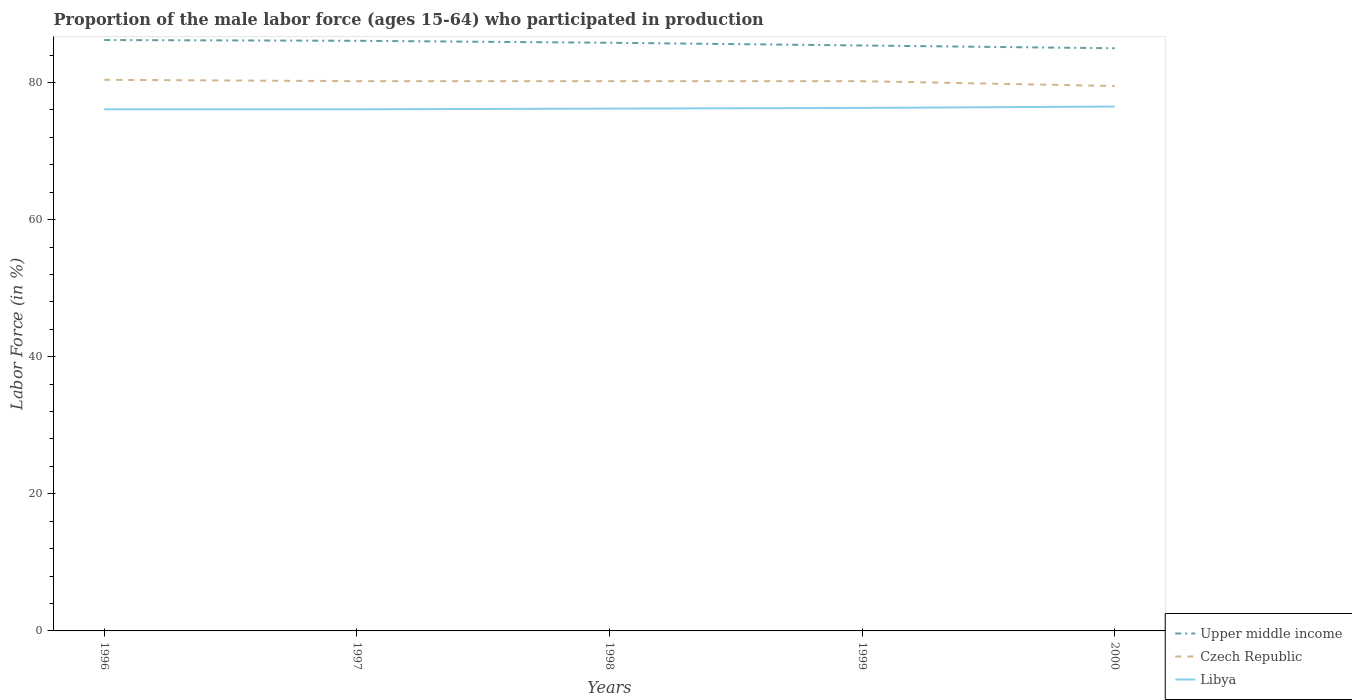How many different coloured lines are there?
Your answer should be very brief. 3. Across all years, what is the maximum proportion of the male labor force who participated in production in Upper middle income?
Offer a terse response. 85. In which year was the proportion of the male labor force who participated in production in Czech Republic maximum?
Offer a very short reply. 2000. What is the total proportion of the male labor force who participated in production in Libya in the graph?
Your answer should be very brief. -0.4. What is the difference between the highest and the second highest proportion of the male labor force who participated in production in Libya?
Provide a succinct answer. 0.4. Is the proportion of the male labor force who participated in production in Czech Republic strictly greater than the proportion of the male labor force who participated in production in Libya over the years?
Give a very brief answer. No. What is the difference between two consecutive major ticks on the Y-axis?
Your answer should be very brief. 20. Does the graph contain grids?
Your answer should be compact. No. Where does the legend appear in the graph?
Ensure brevity in your answer.  Bottom right. What is the title of the graph?
Make the answer very short. Proportion of the male labor force (ages 15-64) who participated in production. Does "Tonga" appear as one of the legend labels in the graph?
Offer a terse response. No. What is the Labor Force (in %) in Upper middle income in 1996?
Keep it short and to the point. 86.2. What is the Labor Force (in %) in Czech Republic in 1996?
Offer a terse response. 80.4. What is the Labor Force (in %) in Libya in 1996?
Provide a short and direct response. 76.1. What is the Labor Force (in %) of Upper middle income in 1997?
Your answer should be very brief. 86.09. What is the Labor Force (in %) in Czech Republic in 1997?
Your response must be concise. 80.2. What is the Labor Force (in %) of Libya in 1997?
Offer a terse response. 76.1. What is the Labor Force (in %) of Upper middle income in 1998?
Your answer should be very brief. 85.81. What is the Labor Force (in %) of Czech Republic in 1998?
Ensure brevity in your answer.  80.2. What is the Labor Force (in %) in Libya in 1998?
Ensure brevity in your answer.  76.2. What is the Labor Force (in %) in Upper middle income in 1999?
Your answer should be very brief. 85.41. What is the Labor Force (in %) in Czech Republic in 1999?
Your response must be concise. 80.2. What is the Labor Force (in %) in Libya in 1999?
Your answer should be compact. 76.3. What is the Labor Force (in %) in Upper middle income in 2000?
Offer a terse response. 85. What is the Labor Force (in %) in Czech Republic in 2000?
Provide a succinct answer. 79.5. What is the Labor Force (in %) in Libya in 2000?
Ensure brevity in your answer.  76.5. Across all years, what is the maximum Labor Force (in %) in Upper middle income?
Your answer should be compact. 86.2. Across all years, what is the maximum Labor Force (in %) of Czech Republic?
Keep it short and to the point. 80.4. Across all years, what is the maximum Labor Force (in %) of Libya?
Give a very brief answer. 76.5. Across all years, what is the minimum Labor Force (in %) of Upper middle income?
Offer a terse response. 85. Across all years, what is the minimum Labor Force (in %) of Czech Republic?
Provide a short and direct response. 79.5. Across all years, what is the minimum Labor Force (in %) of Libya?
Ensure brevity in your answer.  76.1. What is the total Labor Force (in %) of Upper middle income in the graph?
Offer a very short reply. 428.51. What is the total Labor Force (in %) of Czech Republic in the graph?
Ensure brevity in your answer.  400.5. What is the total Labor Force (in %) of Libya in the graph?
Make the answer very short. 381.2. What is the difference between the Labor Force (in %) in Upper middle income in 1996 and that in 1997?
Offer a terse response. 0.11. What is the difference between the Labor Force (in %) in Upper middle income in 1996 and that in 1998?
Provide a short and direct response. 0.4. What is the difference between the Labor Force (in %) of Libya in 1996 and that in 1998?
Your answer should be very brief. -0.1. What is the difference between the Labor Force (in %) of Upper middle income in 1996 and that in 1999?
Keep it short and to the point. 0.79. What is the difference between the Labor Force (in %) in Libya in 1996 and that in 1999?
Give a very brief answer. -0.2. What is the difference between the Labor Force (in %) in Upper middle income in 1996 and that in 2000?
Your answer should be very brief. 1.2. What is the difference between the Labor Force (in %) in Upper middle income in 1997 and that in 1998?
Offer a terse response. 0.29. What is the difference between the Labor Force (in %) in Libya in 1997 and that in 1998?
Provide a short and direct response. -0.1. What is the difference between the Labor Force (in %) in Upper middle income in 1997 and that in 1999?
Provide a succinct answer. 0.68. What is the difference between the Labor Force (in %) in Czech Republic in 1997 and that in 1999?
Offer a very short reply. 0. What is the difference between the Labor Force (in %) in Libya in 1997 and that in 1999?
Offer a terse response. -0.2. What is the difference between the Labor Force (in %) of Upper middle income in 1997 and that in 2000?
Keep it short and to the point. 1.09. What is the difference between the Labor Force (in %) in Upper middle income in 1998 and that in 1999?
Your answer should be very brief. 0.4. What is the difference between the Labor Force (in %) in Libya in 1998 and that in 1999?
Your answer should be compact. -0.1. What is the difference between the Labor Force (in %) in Upper middle income in 1998 and that in 2000?
Provide a succinct answer. 0.8. What is the difference between the Labor Force (in %) in Czech Republic in 1998 and that in 2000?
Give a very brief answer. 0.7. What is the difference between the Labor Force (in %) of Libya in 1998 and that in 2000?
Your response must be concise. -0.3. What is the difference between the Labor Force (in %) of Upper middle income in 1999 and that in 2000?
Make the answer very short. 0.41. What is the difference between the Labor Force (in %) of Upper middle income in 1996 and the Labor Force (in %) of Czech Republic in 1997?
Give a very brief answer. 6. What is the difference between the Labor Force (in %) in Upper middle income in 1996 and the Labor Force (in %) in Libya in 1997?
Provide a succinct answer. 10.1. What is the difference between the Labor Force (in %) in Czech Republic in 1996 and the Labor Force (in %) in Libya in 1997?
Your response must be concise. 4.3. What is the difference between the Labor Force (in %) of Upper middle income in 1996 and the Labor Force (in %) of Czech Republic in 1998?
Offer a terse response. 6. What is the difference between the Labor Force (in %) of Upper middle income in 1996 and the Labor Force (in %) of Libya in 1998?
Keep it short and to the point. 10. What is the difference between the Labor Force (in %) in Upper middle income in 1996 and the Labor Force (in %) in Czech Republic in 1999?
Your answer should be compact. 6. What is the difference between the Labor Force (in %) in Upper middle income in 1996 and the Labor Force (in %) in Libya in 1999?
Make the answer very short. 9.9. What is the difference between the Labor Force (in %) of Upper middle income in 1996 and the Labor Force (in %) of Czech Republic in 2000?
Provide a short and direct response. 6.7. What is the difference between the Labor Force (in %) of Upper middle income in 1996 and the Labor Force (in %) of Libya in 2000?
Offer a terse response. 9.7. What is the difference between the Labor Force (in %) in Czech Republic in 1996 and the Labor Force (in %) in Libya in 2000?
Provide a succinct answer. 3.9. What is the difference between the Labor Force (in %) of Upper middle income in 1997 and the Labor Force (in %) of Czech Republic in 1998?
Offer a very short reply. 5.89. What is the difference between the Labor Force (in %) of Upper middle income in 1997 and the Labor Force (in %) of Libya in 1998?
Offer a terse response. 9.89. What is the difference between the Labor Force (in %) in Czech Republic in 1997 and the Labor Force (in %) in Libya in 1998?
Make the answer very short. 4. What is the difference between the Labor Force (in %) of Upper middle income in 1997 and the Labor Force (in %) of Czech Republic in 1999?
Make the answer very short. 5.89. What is the difference between the Labor Force (in %) of Upper middle income in 1997 and the Labor Force (in %) of Libya in 1999?
Provide a short and direct response. 9.79. What is the difference between the Labor Force (in %) in Czech Republic in 1997 and the Labor Force (in %) in Libya in 1999?
Your answer should be compact. 3.9. What is the difference between the Labor Force (in %) in Upper middle income in 1997 and the Labor Force (in %) in Czech Republic in 2000?
Provide a short and direct response. 6.59. What is the difference between the Labor Force (in %) of Upper middle income in 1997 and the Labor Force (in %) of Libya in 2000?
Offer a terse response. 9.59. What is the difference between the Labor Force (in %) in Czech Republic in 1997 and the Labor Force (in %) in Libya in 2000?
Provide a succinct answer. 3.7. What is the difference between the Labor Force (in %) in Upper middle income in 1998 and the Labor Force (in %) in Czech Republic in 1999?
Your answer should be compact. 5.61. What is the difference between the Labor Force (in %) of Upper middle income in 1998 and the Labor Force (in %) of Libya in 1999?
Your answer should be compact. 9.51. What is the difference between the Labor Force (in %) in Czech Republic in 1998 and the Labor Force (in %) in Libya in 1999?
Offer a terse response. 3.9. What is the difference between the Labor Force (in %) of Upper middle income in 1998 and the Labor Force (in %) of Czech Republic in 2000?
Offer a terse response. 6.31. What is the difference between the Labor Force (in %) of Upper middle income in 1998 and the Labor Force (in %) of Libya in 2000?
Make the answer very short. 9.31. What is the difference between the Labor Force (in %) in Czech Republic in 1998 and the Labor Force (in %) in Libya in 2000?
Keep it short and to the point. 3.7. What is the difference between the Labor Force (in %) of Upper middle income in 1999 and the Labor Force (in %) of Czech Republic in 2000?
Your answer should be very brief. 5.91. What is the difference between the Labor Force (in %) in Upper middle income in 1999 and the Labor Force (in %) in Libya in 2000?
Your answer should be very brief. 8.91. What is the average Labor Force (in %) of Upper middle income per year?
Offer a very short reply. 85.7. What is the average Labor Force (in %) of Czech Republic per year?
Provide a short and direct response. 80.1. What is the average Labor Force (in %) of Libya per year?
Provide a succinct answer. 76.24. In the year 1996, what is the difference between the Labor Force (in %) in Upper middle income and Labor Force (in %) in Czech Republic?
Keep it short and to the point. 5.8. In the year 1996, what is the difference between the Labor Force (in %) of Upper middle income and Labor Force (in %) of Libya?
Provide a short and direct response. 10.1. In the year 1997, what is the difference between the Labor Force (in %) of Upper middle income and Labor Force (in %) of Czech Republic?
Provide a succinct answer. 5.89. In the year 1997, what is the difference between the Labor Force (in %) of Upper middle income and Labor Force (in %) of Libya?
Provide a short and direct response. 9.99. In the year 1998, what is the difference between the Labor Force (in %) in Upper middle income and Labor Force (in %) in Czech Republic?
Provide a succinct answer. 5.61. In the year 1998, what is the difference between the Labor Force (in %) in Upper middle income and Labor Force (in %) in Libya?
Offer a very short reply. 9.61. In the year 1999, what is the difference between the Labor Force (in %) of Upper middle income and Labor Force (in %) of Czech Republic?
Offer a terse response. 5.21. In the year 1999, what is the difference between the Labor Force (in %) of Upper middle income and Labor Force (in %) of Libya?
Your answer should be very brief. 9.11. In the year 1999, what is the difference between the Labor Force (in %) in Czech Republic and Labor Force (in %) in Libya?
Give a very brief answer. 3.9. In the year 2000, what is the difference between the Labor Force (in %) of Upper middle income and Labor Force (in %) of Czech Republic?
Make the answer very short. 5.5. In the year 2000, what is the difference between the Labor Force (in %) of Upper middle income and Labor Force (in %) of Libya?
Give a very brief answer. 8.5. What is the ratio of the Labor Force (in %) of Czech Republic in 1996 to that in 1998?
Offer a very short reply. 1. What is the ratio of the Labor Force (in %) in Libya in 1996 to that in 1998?
Provide a short and direct response. 1. What is the ratio of the Labor Force (in %) of Upper middle income in 1996 to that in 1999?
Give a very brief answer. 1.01. What is the ratio of the Labor Force (in %) in Libya in 1996 to that in 1999?
Ensure brevity in your answer.  1. What is the ratio of the Labor Force (in %) in Upper middle income in 1996 to that in 2000?
Provide a succinct answer. 1.01. What is the ratio of the Labor Force (in %) of Czech Republic in 1996 to that in 2000?
Ensure brevity in your answer.  1.01. What is the ratio of the Labor Force (in %) in Czech Republic in 1997 to that in 1998?
Give a very brief answer. 1. What is the ratio of the Labor Force (in %) in Libya in 1997 to that in 1998?
Ensure brevity in your answer.  1. What is the ratio of the Labor Force (in %) in Czech Republic in 1997 to that in 1999?
Give a very brief answer. 1. What is the ratio of the Labor Force (in %) of Libya in 1997 to that in 1999?
Ensure brevity in your answer.  1. What is the ratio of the Labor Force (in %) of Upper middle income in 1997 to that in 2000?
Offer a very short reply. 1.01. What is the ratio of the Labor Force (in %) of Czech Republic in 1997 to that in 2000?
Ensure brevity in your answer.  1.01. What is the ratio of the Labor Force (in %) in Libya in 1997 to that in 2000?
Provide a short and direct response. 0.99. What is the ratio of the Labor Force (in %) of Czech Republic in 1998 to that in 1999?
Offer a very short reply. 1. What is the ratio of the Labor Force (in %) in Libya in 1998 to that in 1999?
Provide a short and direct response. 1. What is the ratio of the Labor Force (in %) of Upper middle income in 1998 to that in 2000?
Provide a succinct answer. 1.01. What is the ratio of the Labor Force (in %) of Czech Republic in 1998 to that in 2000?
Give a very brief answer. 1.01. What is the ratio of the Labor Force (in %) of Czech Republic in 1999 to that in 2000?
Offer a very short reply. 1.01. What is the ratio of the Labor Force (in %) of Libya in 1999 to that in 2000?
Give a very brief answer. 1. What is the difference between the highest and the second highest Labor Force (in %) of Upper middle income?
Keep it short and to the point. 0.11. What is the difference between the highest and the second highest Labor Force (in %) in Czech Republic?
Provide a short and direct response. 0.2. What is the difference between the highest and the second highest Labor Force (in %) of Libya?
Offer a terse response. 0.2. What is the difference between the highest and the lowest Labor Force (in %) in Upper middle income?
Ensure brevity in your answer.  1.2. What is the difference between the highest and the lowest Labor Force (in %) in Libya?
Provide a succinct answer. 0.4. 